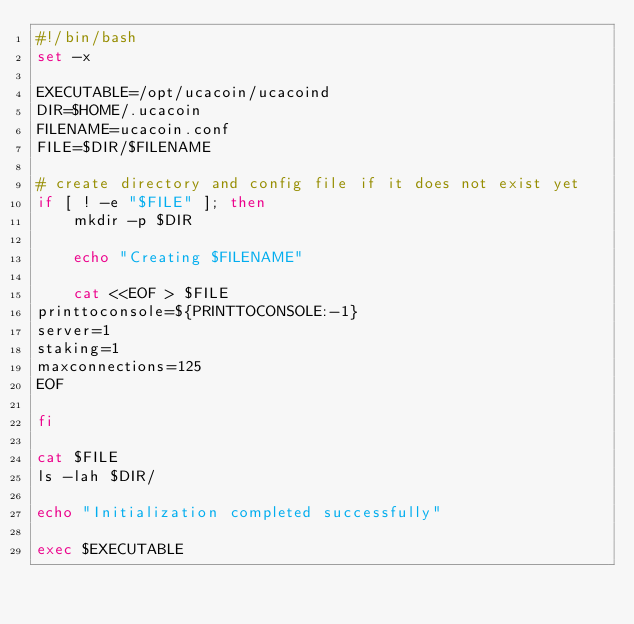Convert code to text. <code><loc_0><loc_0><loc_500><loc_500><_Bash_>#!/bin/bash
set -x

EXECUTABLE=/opt/ucacoin/ucacoind
DIR=$HOME/.ucacoin
FILENAME=ucacoin.conf
FILE=$DIR/$FILENAME

# create directory and config file if it does not exist yet
if [ ! -e "$FILE" ]; then
    mkdir -p $DIR

    echo "Creating $FILENAME"

    cat <<EOF > $FILE
printtoconsole=${PRINTTOCONSOLE:-1}
server=1
staking=1
maxconnections=125
EOF

fi

cat $FILE
ls -lah $DIR/

echo "Initialization completed successfully"

exec $EXECUTABLE</code> 